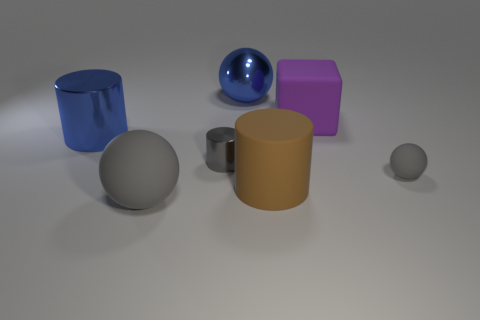What number of other things are there of the same size as the metallic sphere?
Your answer should be very brief. 4. There is a blue object that is the same shape as the brown rubber thing; what is its size?
Offer a terse response. Large. There is another matte sphere that is the same color as the small rubber ball; what is its size?
Provide a short and direct response. Large. Do the large gray thing and the large blue cylinder have the same material?
Ensure brevity in your answer.  No. There is a big cylinder in front of the gray metallic cylinder; how many things are to the left of it?
Keep it short and to the point. 4. What number of purple objects are cylinders or big things?
Your answer should be compact. 1. What is the shape of the gray rubber thing on the right side of the big cylinder in front of the blue object that is in front of the metal sphere?
Offer a very short reply. Sphere. The rubber cylinder that is the same size as the block is what color?
Ensure brevity in your answer.  Brown. How many blue things have the same shape as the gray metal object?
Keep it short and to the point. 1. There is a gray shiny thing; does it have the same size as the rubber sphere that is behind the brown thing?
Your answer should be very brief. Yes. 